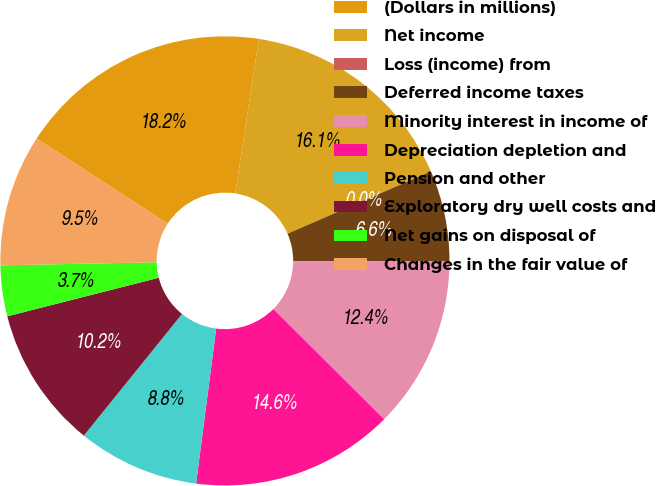Convert chart. <chart><loc_0><loc_0><loc_500><loc_500><pie_chart><fcel>(Dollars in millions)<fcel>Net income<fcel>Loss (income) from<fcel>Deferred income taxes<fcel>Minority interest in income of<fcel>Depreciation depletion and<fcel>Pension and other<fcel>Exploratory dry well costs and<fcel>Net gains on disposal of<fcel>Changes in the fair value of<nl><fcel>18.24%<fcel>16.05%<fcel>0.01%<fcel>6.57%<fcel>12.41%<fcel>14.59%<fcel>8.76%<fcel>10.22%<fcel>3.65%<fcel>9.49%<nl></chart> 